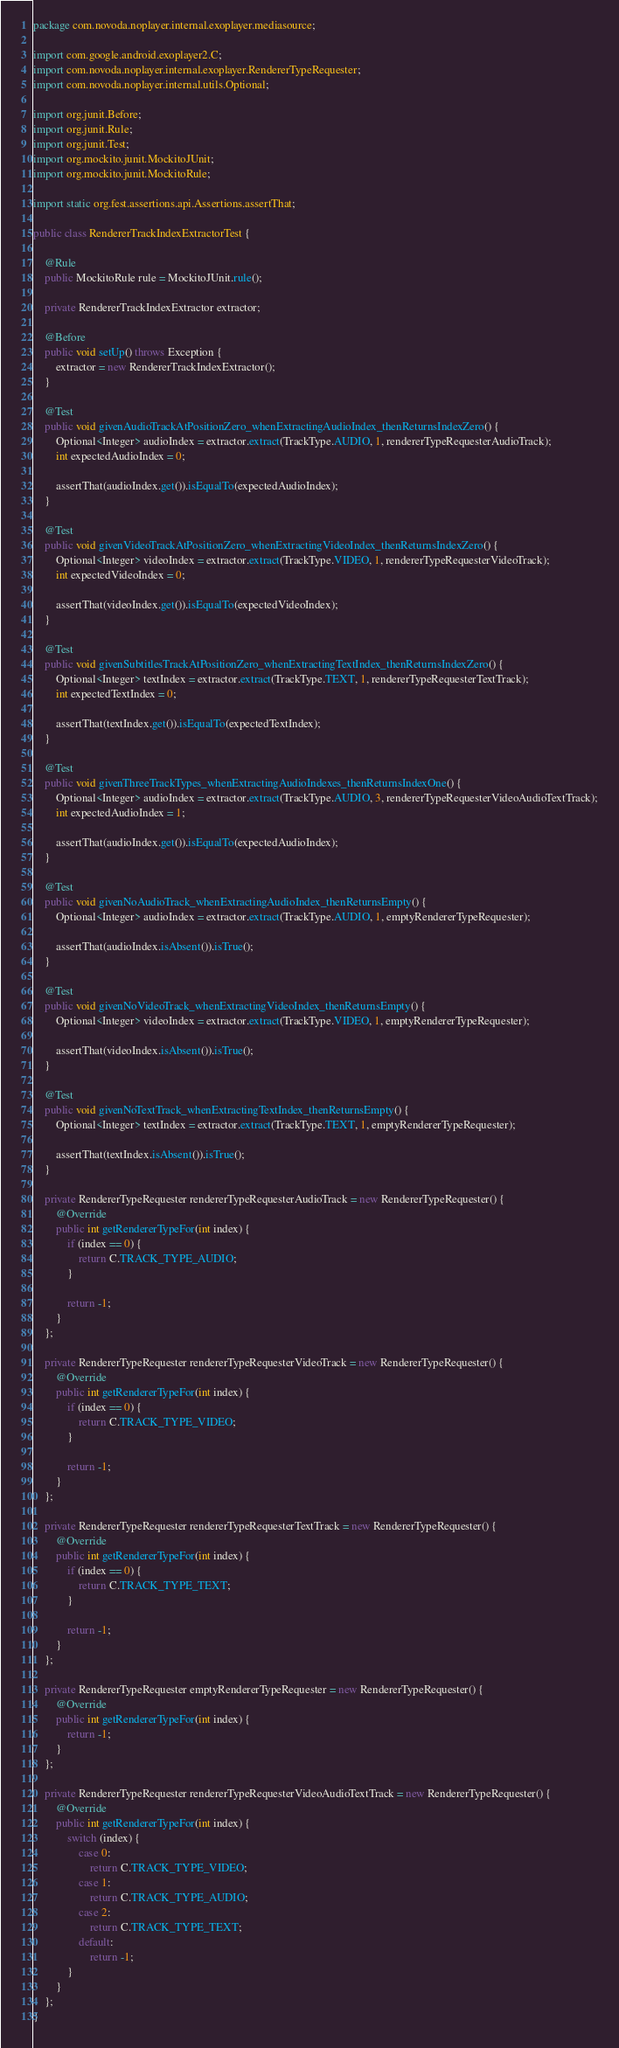Convert code to text. <code><loc_0><loc_0><loc_500><loc_500><_Java_>package com.novoda.noplayer.internal.exoplayer.mediasource;

import com.google.android.exoplayer2.C;
import com.novoda.noplayer.internal.exoplayer.RendererTypeRequester;
import com.novoda.noplayer.internal.utils.Optional;

import org.junit.Before;
import org.junit.Rule;
import org.junit.Test;
import org.mockito.junit.MockitoJUnit;
import org.mockito.junit.MockitoRule;

import static org.fest.assertions.api.Assertions.assertThat;

public class RendererTrackIndexExtractorTest {

    @Rule
    public MockitoRule rule = MockitoJUnit.rule();

    private RendererTrackIndexExtractor extractor;

    @Before
    public void setUp() throws Exception {
        extractor = new RendererTrackIndexExtractor();
    }

    @Test
    public void givenAudioTrackAtPositionZero_whenExtractingAudioIndex_thenReturnsIndexZero() {
        Optional<Integer> audioIndex = extractor.extract(TrackType.AUDIO, 1, rendererTypeRequesterAudioTrack);
        int expectedAudioIndex = 0;

        assertThat(audioIndex.get()).isEqualTo(expectedAudioIndex);
    }

    @Test
    public void givenVideoTrackAtPositionZero_whenExtractingVideoIndex_thenReturnsIndexZero() {
        Optional<Integer> videoIndex = extractor.extract(TrackType.VIDEO, 1, rendererTypeRequesterVideoTrack);
        int expectedVideoIndex = 0;

        assertThat(videoIndex.get()).isEqualTo(expectedVideoIndex);
    }

    @Test
    public void givenSubtitlesTrackAtPositionZero_whenExtractingTextIndex_thenReturnsIndexZero() {
        Optional<Integer> textIndex = extractor.extract(TrackType.TEXT, 1, rendererTypeRequesterTextTrack);
        int expectedTextIndex = 0;

        assertThat(textIndex.get()).isEqualTo(expectedTextIndex);
    }

    @Test
    public void givenThreeTrackTypes_whenExtractingAudioIndexes_thenReturnsIndexOne() {
        Optional<Integer> audioIndex = extractor.extract(TrackType.AUDIO, 3, rendererTypeRequesterVideoAudioTextTrack);
        int expectedAudioIndex = 1;

        assertThat(audioIndex.get()).isEqualTo(expectedAudioIndex);
    }

    @Test
    public void givenNoAudioTrack_whenExtractingAudioIndex_thenReturnsEmpty() {
        Optional<Integer> audioIndex = extractor.extract(TrackType.AUDIO, 1, emptyRendererTypeRequester);

        assertThat(audioIndex.isAbsent()).isTrue();
    }

    @Test
    public void givenNoVideoTrack_whenExtractingVideoIndex_thenReturnsEmpty() {
        Optional<Integer> videoIndex = extractor.extract(TrackType.VIDEO, 1, emptyRendererTypeRequester);

        assertThat(videoIndex.isAbsent()).isTrue();
    }

    @Test
    public void givenNoTextTrack_whenExtractingTextIndex_thenReturnsEmpty() {
        Optional<Integer> textIndex = extractor.extract(TrackType.TEXT, 1, emptyRendererTypeRequester);

        assertThat(textIndex.isAbsent()).isTrue();
    }

    private RendererTypeRequester rendererTypeRequesterAudioTrack = new RendererTypeRequester() {
        @Override
        public int getRendererTypeFor(int index) {
            if (index == 0) {
                return C.TRACK_TYPE_AUDIO;
            }

            return -1;
        }
    };

    private RendererTypeRequester rendererTypeRequesterVideoTrack = new RendererTypeRequester() {
        @Override
        public int getRendererTypeFor(int index) {
            if (index == 0) {
                return C.TRACK_TYPE_VIDEO;
            }

            return -1;
        }
    };

    private RendererTypeRequester rendererTypeRequesterTextTrack = new RendererTypeRequester() {
        @Override
        public int getRendererTypeFor(int index) {
            if (index == 0) {
                return C.TRACK_TYPE_TEXT;
            }

            return -1;
        }
    };

    private RendererTypeRequester emptyRendererTypeRequester = new RendererTypeRequester() {
        @Override
        public int getRendererTypeFor(int index) {
            return -1;
        }
    };

    private RendererTypeRequester rendererTypeRequesterVideoAudioTextTrack = new RendererTypeRequester() {
        @Override
        public int getRendererTypeFor(int index) {
            switch (index) {
                case 0:
                    return C.TRACK_TYPE_VIDEO;
                case 1:
                    return C.TRACK_TYPE_AUDIO;
                case 2:
                    return C.TRACK_TYPE_TEXT;
                default:
                    return -1;
            }
        }
    };
}
</code> 